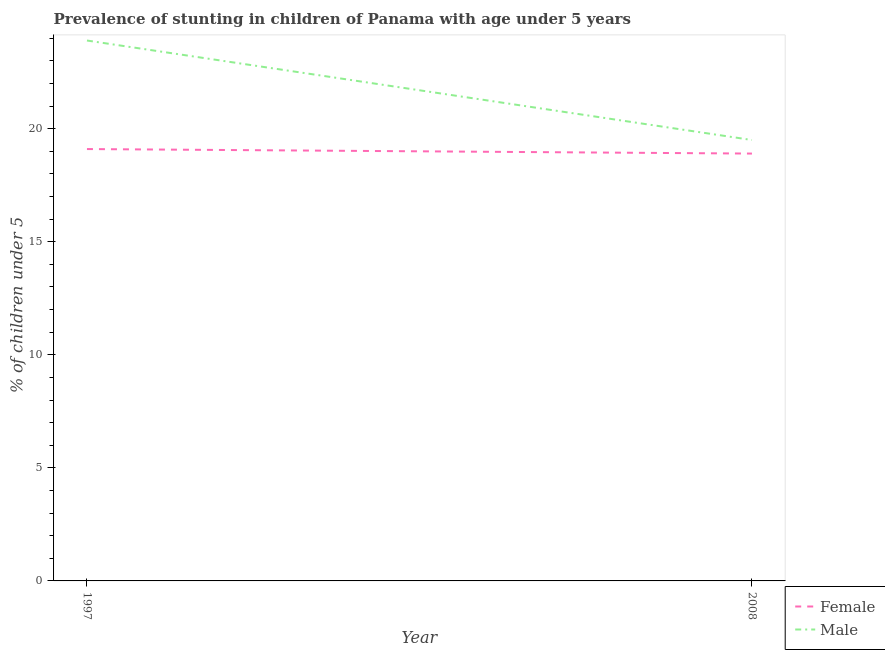How many different coloured lines are there?
Provide a succinct answer. 2. Does the line corresponding to percentage of stunted female children intersect with the line corresponding to percentage of stunted male children?
Provide a short and direct response. No. What is the percentage of stunted male children in 2008?
Your response must be concise. 19.5. Across all years, what is the maximum percentage of stunted male children?
Provide a succinct answer. 23.9. Across all years, what is the minimum percentage of stunted female children?
Your response must be concise. 18.9. In which year was the percentage of stunted male children minimum?
Make the answer very short. 2008. What is the total percentage of stunted male children in the graph?
Provide a succinct answer. 43.4. What is the difference between the percentage of stunted female children in 1997 and that in 2008?
Your answer should be very brief. 0.2. What is the difference between the percentage of stunted female children in 1997 and the percentage of stunted male children in 2008?
Provide a succinct answer. -0.4. In the year 1997, what is the difference between the percentage of stunted female children and percentage of stunted male children?
Offer a terse response. -4.8. What is the ratio of the percentage of stunted male children in 1997 to that in 2008?
Give a very brief answer. 1.23. Does the percentage of stunted male children monotonically increase over the years?
Ensure brevity in your answer.  No. Are the values on the major ticks of Y-axis written in scientific E-notation?
Keep it short and to the point. No. Does the graph contain grids?
Ensure brevity in your answer.  No. How many legend labels are there?
Provide a succinct answer. 2. What is the title of the graph?
Offer a terse response. Prevalence of stunting in children of Panama with age under 5 years. What is the label or title of the Y-axis?
Provide a short and direct response.  % of children under 5. What is the  % of children under 5 of Female in 1997?
Offer a very short reply. 19.1. What is the  % of children under 5 in Male in 1997?
Your answer should be very brief. 23.9. What is the  % of children under 5 in Female in 2008?
Offer a very short reply. 18.9. Across all years, what is the maximum  % of children under 5 in Female?
Your answer should be very brief. 19.1. Across all years, what is the maximum  % of children under 5 in Male?
Provide a short and direct response. 23.9. Across all years, what is the minimum  % of children under 5 in Female?
Give a very brief answer. 18.9. What is the total  % of children under 5 in Male in the graph?
Your answer should be very brief. 43.4. What is the difference between the  % of children under 5 in Male in 1997 and that in 2008?
Keep it short and to the point. 4.4. What is the difference between the  % of children under 5 in Female in 1997 and the  % of children under 5 in Male in 2008?
Keep it short and to the point. -0.4. What is the average  % of children under 5 in Female per year?
Give a very brief answer. 19. What is the average  % of children under 5 in Male per year?
Offer a terse response. 21.7. What is the ratio of the  % of children under 5 of Female in 1997 to that in 2008?
Keep it short and to the point. 1.01. What is the ratio of the  % of children under 5 in Male in 1997 to that in 2008?
Your response must be concise. 1.23. What is the difference between the highest and the second highest  % of children under 5 of Female?
Provide a succinct answer. 0.2. What is the difference between the highest and the second highest  % of children under 5 in Male?
Provide a succinct answer. 4.4. What is the difference between the highest and the lowest  % of children under 5 of Female?
Ensure brevity in your answer.  0.2. 